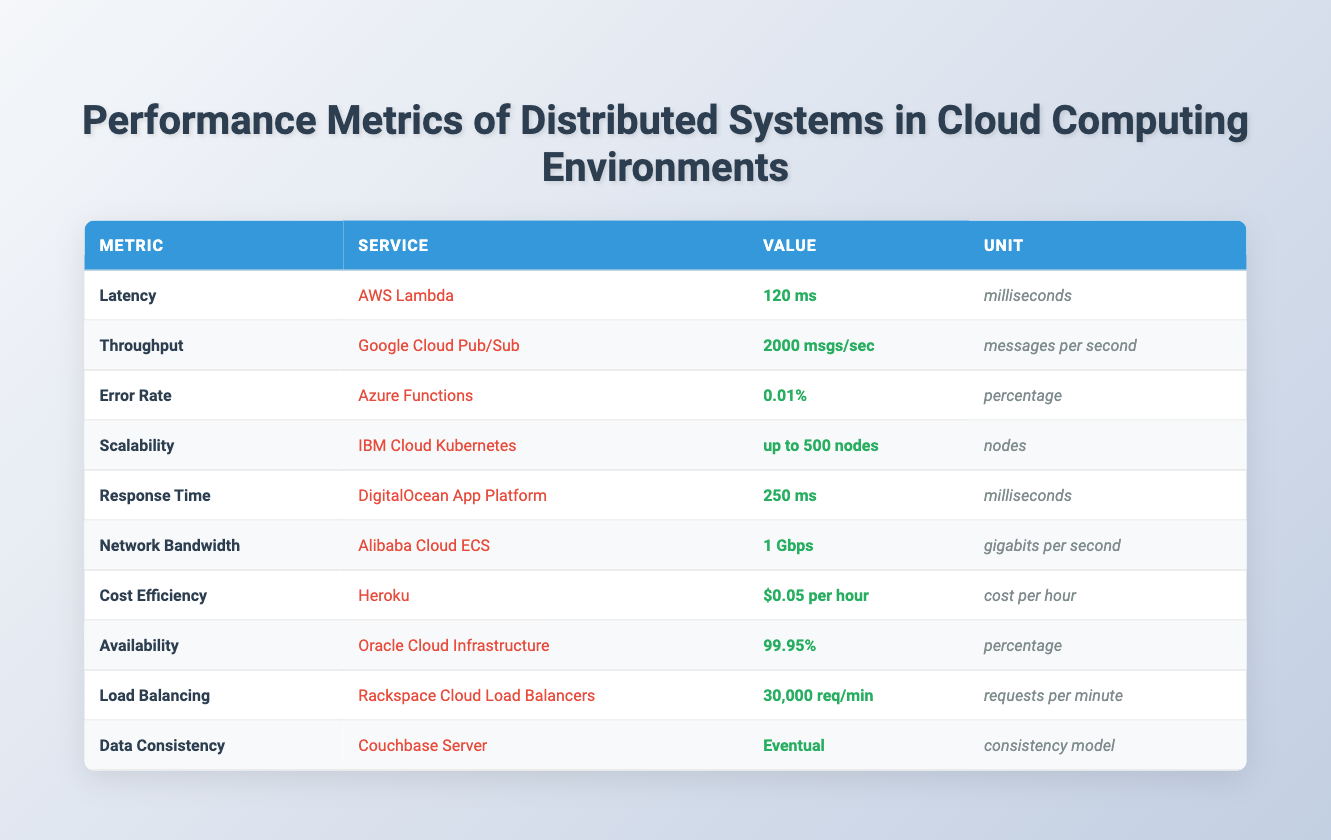What is the latency of AWS Lambda? From the table, the row for AWS Lambda under the "Latency" metric shows a value of "120 ms." Therefore, the latency of AWS Lambda is extracted directly from this row.
Answer: 120 ms Which service has the highest throughput? The highest throughput is found by comparing the values under the "Throughput" metric. The only entry listed is "Google Cloud Pub/Sub" with a value of "2000 msgs/sec." Hence, it has the highest throughput.
Answer: Google Cloud Pub/Sub What is the error rate of Azure Functions? The error rate for Azure Functions can be found in the corresponding row under the "Error Rate" metric. It shows a value of "0.01%." Therefore, the answer is derived from this data.
Answer: 0.01% Is the cost efficiency of Heroku less than $0.10 per hour? The cost efficiency of Heroku is listed as "$0.05 per hour." Since this is less than $0.10, we confirm that the statement is true.
Answer: Yes Which service has the lowest data consistency rating? The data consistency rating in the table for "Couchbase Server" is "Eventual," which implies it is the lowest compared to any stronger models. Thus, it qualifies as the answer to this question.
Answer: Couchbase Server What is the total number of requests per minute supported by Rackspace Cloud Load Balancers? The table reveals that Rackspace Cloud Load Balancers can handle "30,000 req/min." This value is taken directly from the corresponding row for this service.
Answer: 30,000 req/min What is the average latency of the services listed? To find the average latency, I select the only latency values from AWS Lambda (120 ms) and DigitalOcean App Platform (250 ms). Next, I calculate their sum: 120 + 250 = 370 ms, and divide by 2, resulting in an average of 185 ms.
Answer: 185 ms Is the availability of Oracle Cloud Infrastructure greater than 99%? The table provides an availability of "99.95%" for Oracle Cloud Infrastructure, which indeed exceeds 99%. Therefore, the answer is derived from this fact.
Answer: Yes What is the difference in milliseconds between the latency of AWS Lambda and DigitalOcean App Platform? The latency of AWS Lambda is "120 ms" and that of DigitalOcean App Platform is "250 ms." To find the difference: 250 - 120 = 130 ms. Thus, the difference is found through this subtraction.
Answer: 130 ms What is the scalability capacity of IBM Cloud Kubernetes? The scalability metric for IBM Cloud Kubernetes shows a capacity of "up to 500 nodes." This information is directly obtained from the table.
Answer: Up to 500 nodes What services have an availability rating of 99% or higher? Both "Oracle Cloud Infrastructure" with 99.95% and "Azure Functions" with 0.01% in error rate indicate reliability, and the percentage shown qualifies the former service as an available option. Thus, it includes only Oracle Cloud Infrastructure in this case.
Answer: Oracle Cloud Infrastructure 